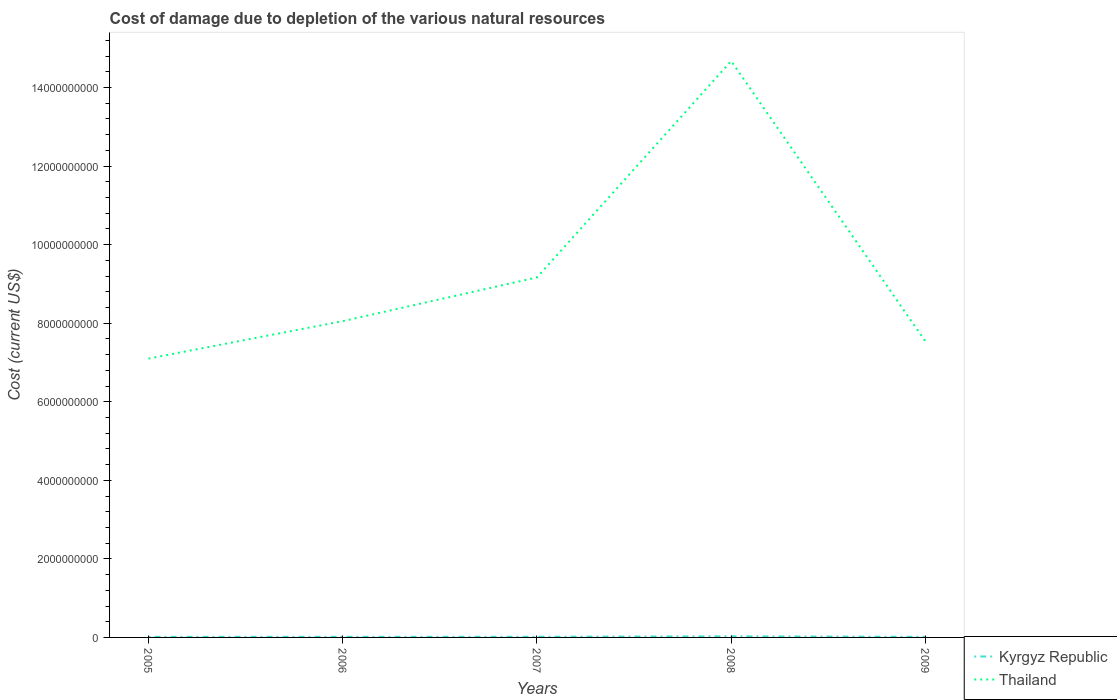How many different coloured lines are there?
Your response must be concise. 2. Does the line corresponding to Thailand intersect with the line corresponding to Kyrgyz Republic?
Your response must be concise. No. Is the number of lines equal to the number of legend labels?
Offer a very short reply. Yes. Across all years, what is the maximum cost of damage caused due to the depletion of various natural resources in Kyrgyz Republic?
Provide a succinct answer. 1.52e+07. In which year was the cost of damage caused due to the depletion of various natural resources in Kyrgyz Republic maximum?
Provide a succinct answer. 2005. What is the total cost of damage caused due to the depletion of various natural resources in Kyrgyz Republic in the graph?
Offer a very short reply. 1.44e+06. What is the difference between the highest and the second highest cost of damage caused due to the depletion of various natural resources in Thailand?
Your answer should be compact. 7.58e+09. What is the difference between the highest and the lowest cost of damage caused due to the depletion of various natural resources in Thailand?
Ensure brevity in your answer.  1. Is the cost of damage caused due to the depletion of various natural resources in Thailand strictly greater than the cost of damage caused due to the depletion of various natural resources in Kyrgyz Republic over the years?
Give a very brief answer. No. How many lines are there?
Keep it short and to the point. 2. Are the values on the major ticks of Y-axis written in scientific E-notation?
Keep it short and to the point. No. Does the graph contain grids?
Provide a succinct answer. No. Where does the legend appear in the graph?
Offer a very short reply. Bottom right. How many legend labels are there?
Provide a succinct answer. 2. What is the title of the graph?
Provide a succinct answer. Cost of damage due to depletion of the various natural resources. What is the label or title of the Y-axis?
Keep it short and to the point. Cost (current US$). What is the Cost (current US$) of Kyrgyz Republic in 2005?
Your response must be concise. 1.52e+07. What is the Cost (current US$) of Thailand in 2005?
Your answer should be very brief. 7.10e+09. What is the Cost (current US$) of Kyrgyz Republic in 2006?
Your response must be concise. 1.58e+07. What is the Cost (current US$) in Thailand in 2006?
Give a very brief answer. 8.05e+09. What is the Cost (current US$) in Kyrgyz Republic in 2007?
Give a very brief answer. 1.73e+07. What is the Cost (current US$) of Thailand in 2007?
Keep it short and to the point. 9.17e+09. What is the Cost (current US$) in Kyrgyz Republic in 2008?
Offer a very short reply. 2.81e+07. What is the Cost (current US$) of Thailand in 2008?
Make the answer very short. 1.47e+1. What is the Cost (current US$) in Kyrgyz Republic in 2009?
Your answer should be very brief. 1.58e+07. What is the Cost (current US$) of Thailand in 2009?
Ensure brevity in your answer.  7.54e+09. Across all years, what is the maximum Cost (current US$) in Kyrgyz Republic?
Offer a very short reply. 2.81e+07. Across all years, what is the maximum Cost (current US$) of Thailand?
Make the answer very short. 1.47e+1. Across all years, what is the minimum Cost (current US$) of Kyrgyz Republic?
Keep it short and to the point. 1.52e+07. Across all years, what is the minimum Cost (current US$) of Thailand?
Give a very brief answer. 7.10e+09. What is the total Cost (current US$) in Kyrgyz Republic in the graph?
Make the answer very short. 9.22e+07. What is the total Cost (current US$) in Thailand in the graph?
Provide a short and direct response. 4.65e+1. What is the difference between the Cost (current US$) in Kyrgyz Republic in 2005 and that in 2006?
Give a very brief answer. -6.60e+05. What is the difference between the Cost (current US$) in Thailand in 2005 and that in 2006?
Your response must be concise. -9.52e+08. What is the difference between the Cost (current US$) of Kyrgyz Republic in 2005 and that in 2007?
Give a very brief answer. -2.08e+06. What is the difference between the Cost (current US$) in Thailand in 2005 and that in 2007?
Your answer should be very brief. -2.07e+09. What is the difference between the Cost (current US$) in Kyrgyz Republic in 2005 and that in 2008?
Ensure brevity in your answer.  -1.29e+07. What is the difference between the Cost (current US$) in Thailand in 2005 and that in 2008?
Offer a terse response. -7.58e+09. What is the difference between the Cost (current US$) in Kyrgyz Republic in 2005 and that in 2009?
Ensure brevity in your answer.  -6.46e+05. What is the difference between the Cost (current US$) in Thailand in 2005 and that in 2009?
Ensure brevity in your answer.  -4.39e+08. What is the difference between the Cost (current US$) in Kyrgyz Republic in 2006 and that in 2007?
Offer a very short reply. -1.42e+06. What is the difference between the Cost (current US$) of Thailand in 2006 and that in 2007?
Your answer should be compact. -1.11e+09. What is the difference between the Cost (current US$) in Kyrgyz Republic in 2006 and that in 2008?
Offer a very short reply. -1.22e+07. What is the difference between the Cost (current US$) in Thailand in 2006 and that in 2008?
Give a very brief answer. -6.62e+09. What is the difference between the Cost (current US$) in Kyrgyz Republic in 2006 and that in 2009?
Your response must be concise. 1.34e+04. What is the difference between the Cost (current US$) of Thailand in 2006 and that in 2009?
Ensure brevity in your answer.  5.13e+08. What is the difference between the Cost (current US$) in Kyrgyz Republic in 2007 and that in 2008?
Keep it short and to the point. -1.08e+07. What is the difference between the Cost (current US$) in Thailand in 2007 and that in 2008?
Make the answer very short. -5.51e+09. What is the difference between the Cost (current US$) in Kyrgyz Republic in 2007 and that in 2009?
Your answer should be compact. 1.44e+06. What is the difference between the Cost (current US$) in Thailand in 2007 and that in 2009?
Provide a short and direct response. 1.63e+09. What is the difference between the Cost (current US$) in Kyrgyz Republic in 2008 and that in 2009?
Offer a very short reply. 1.23e+07. What is the difference between the Cost (current US$) in Thailand in 2008 and that in 2009?
Provide a succinct answer. 7.14e+09. What is the difference between the Cost (current US$) in Kyrgyz Republic in 2005 and the Cost (current US$) in Thailand in 2006?
Your response must be concise. -8.04e+09. What is the difference between the Cost (current US$) of Kyrgyz Republic in 2005 and the Cost (current US$) of Thailand in 2007?
Give a very brief answer. -9.15e+09. What is the difference between the Cost (current US$) in Kyrgyz Republic in 2005 and the Cost (current US$) in Thailand in 2008?
Your response must be concise. -1.47e+1. What is the difference between the Cost (current US$) of Kyrgyz Republic in 2005 and the Cost (current US$) of Thailand in 2009?
Provide a short and direct response. -7.52e+09. What is the difference between the Cost (current US$) of Kyrgyz Republic in 2006 and the Cost (current US$) of Thailand in 2007?
Your response must be concise. -9.15e+09. What is the difference between the Cost (current US$) in Kyrgyz Republic in 2006 and the Cost (current US$) in Thailand in 2008?
Make the answer very short. -1.47e+1. What is the difference between the Cost (current US$) of Kyrgyz Republic in 2006 and the Cost (current US$) of Thailand in 2009?
Offer a terse response. -7.52e+09. What is the difference between the Cost (current US$) of Kyrgyz Republic in 2007 and the Cost (current US$) of Thailand in 2008?
Offer a very short reply. -1.47e+1. What is the difference between the Cost (current US$) of Kyrgyz Republic in 2007 and the Cost (current US$) of Thailand in 2009?
Offer a very short reply. -7.52e+09. What is the difference between the Cost (current US$) in Kyrgyz Republic in 2008 and the Cost (current US$) in Thailand in 2009?
Provide a succinct answer. -7.51e+09. What is the average Cost (current US$) of Kyrgyz Republic per year?
Offer a very short reply. 1.84e+07. What is the average Cost (current US$) of Thailand per year?
Keep it short and to the point. 9.31e+09. In the year 2005, what is the difference between the Cost (current US$) in Kyrgyz Republic and Cost (current US$) in Thailand?
Provide a succinct answer. -7.08e+09. In the year 2006, what is the difference between the Cost (current US$) of Kyrgyz Republic and Cost (current US$) of Thailand?
Give a very brief answer. -8.04e+09. In the year 2007, what is the difference between the Cost (current US$) in Kyrgyz Republic and Cost (current US$) in Thailand?
Offer a very short reply. -9.15e+09. In the year 2008, what is the difference between the Cost (current US$) in Kyrgyz Republic and Cost (current US$) in Thailand?
Your answer should be compact. -1.46e+1. In the year 2009, what is the difference between the Cost (current US$) in Kyrgyz Republic and Cost (current US$) in Thailand?
Make the answer very short. -7.52e+09. What is the ratio of the Cost (current US$) of Kyrgyz Republic in 2005 to that in 2006?
Your response must be concise. 0.96. What is the ratio of the Cost (current US$) in Thailand in 2005 to that in 2006?
Your answer should be very brief. 0.88. What is the ratio of the Cost (current US$) of Kyrgyz Republic in 2005 to that in 2007?
Offer a terse response. 0.88. What is the ratio of the Cost (current US$) of Thailand in 2005 to that in 2007?
Offer a very short reply. 0.77. What is the ratio of the Cost (current US$) in Kyrgyz Republic in 2005 to that in 2008?
Offer a terse response. 0.54. What is the ratio of the Cost (current US$) of Thailand in 2005 to that in 2008?
Keep it short and to the point. 0.48. What is the ratio of the Cost (current US$) in Kyrgyz Republic in 2005 to that in 2009?
Offer a terse response. 0.96. What is the ratio of the Cost (current US$) of Thailand in 2005 to that in 2009?
Your answer should be very brief. 0.94. What is the ratio of the Cost (current US$) in Kyrgyz Republic in 2006 to that in 2007?
Provide a succinct answer. 0.92. What is the ratio of the Cost (current US$) of Thailand in 2006 to that in 2007?
Provide a succinct answer. 0.88. What is the ratio of the Cost (current US$) of Kyrgyz Republic in 2006 to that in 2008?
Your answer should be compact. 0.56. What is the ratio of the Cost (current US$) of Thailand in 2006 to that in 2008?
Your response must be concise. 0.55. What is the ratio of the Cost (current US$) of Kyrgyz Republic in 2006 to that in 2009?
Ensure brevity in your answer.  1. What is the ratio of the Cost (current US$) in Thailand in 2006 to that in 2009?
Offer a terse response. 1.07. What is the ratio of the Cost (current US$) of Kyrgyz Republic in 2007 to that in 2008?
Your answer should be compact. 0.61. What is the ratio of the Cost (current US$) of Thailand in 2007 to that in 2008?
Provide a short and direct response. 0.62. What is the ratio of the Cost (current US$) in Kyrgyz Republic in 2007 to that in 2009?
Offer a very short reply. 1.09. What is the ratio of the Cost (current US$) in Thailand in 2007 to that in 2009?
Your answer should be compact. 1.22. What is the ratio of the Cost (current US$) of Kyrgyz Republic in 2008 to that in 2009?
Ensure brevity in your answer.  1.77. What is the ratio of the Cost (current US$) of Thailand in 2008 to that in 2009?
Provide a succinct answer. 1.95. What is the difference between the highest and the second highest Cost (current US$) of Kyrgyz Republic?
Make the answer very short. 1.08e+07. What is the difference between the highest and the second highest Cost (current US$) of Thailand?
Give a very brief answer. 5.51e+09. What is the difference between the highest and the lowest Cost (current US$) of Kyrgyz Republic?
Provide a succinct answer. 1.29e+07. What is the difference between the highest and the lowest Cost (current US$) in Thailand?
Your answer should be very brief. 7.58e+09. 